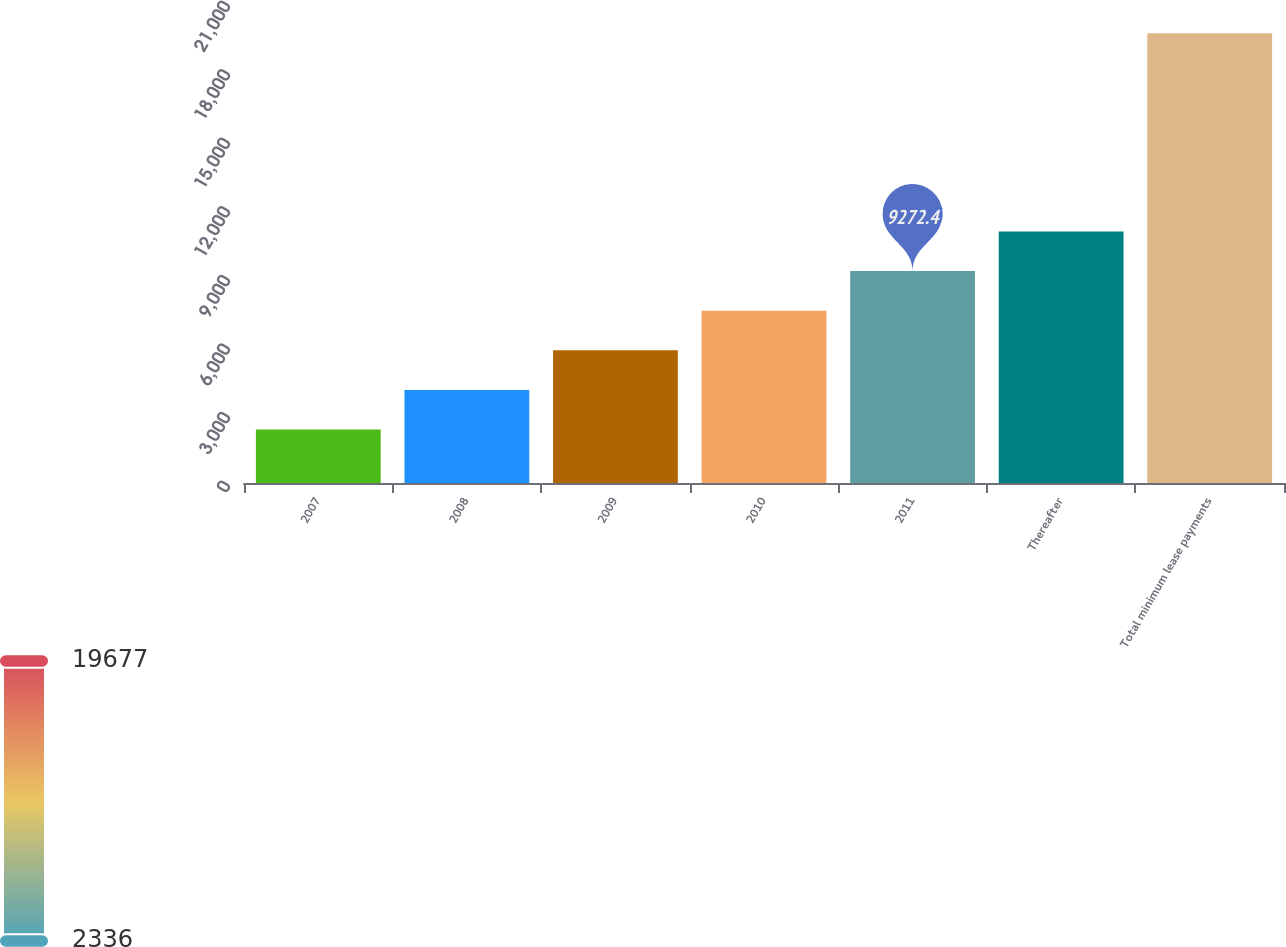<chart> <loc_0><loc_0><loc_500><loc_500><bar_chart><fcel>2007<fcel>2008<fcel>2009<fcel>2010<fcel>2011<fcel>Thereafter<fcel>Total minimum lease payments<nl><fcel>2336<fcel>4070.1<fcel>5804.2<fcel>7538.3<fcel>9272.4<fcel>11006.5<fcel>19677<nl></chart> 